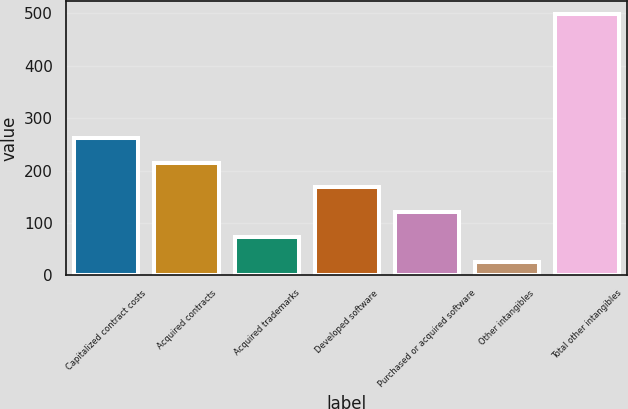<chart> <loc_0><loc_0><loc_500><loc_500><bar_chart><fcel>Capitalized contract costs<fcel>Acquired contracts<fcel>Acquired trademarks<fcel>Developed software<fcel>Purchased or acquired software<fcel>Other intangibles<fcel>Total other intangibles<nl><fcel>262.35<fcel>215<fcel>72.95<fcel>167.65<fcel>120.3<fcel>25.6<fcel>499.1<nl></chart> 